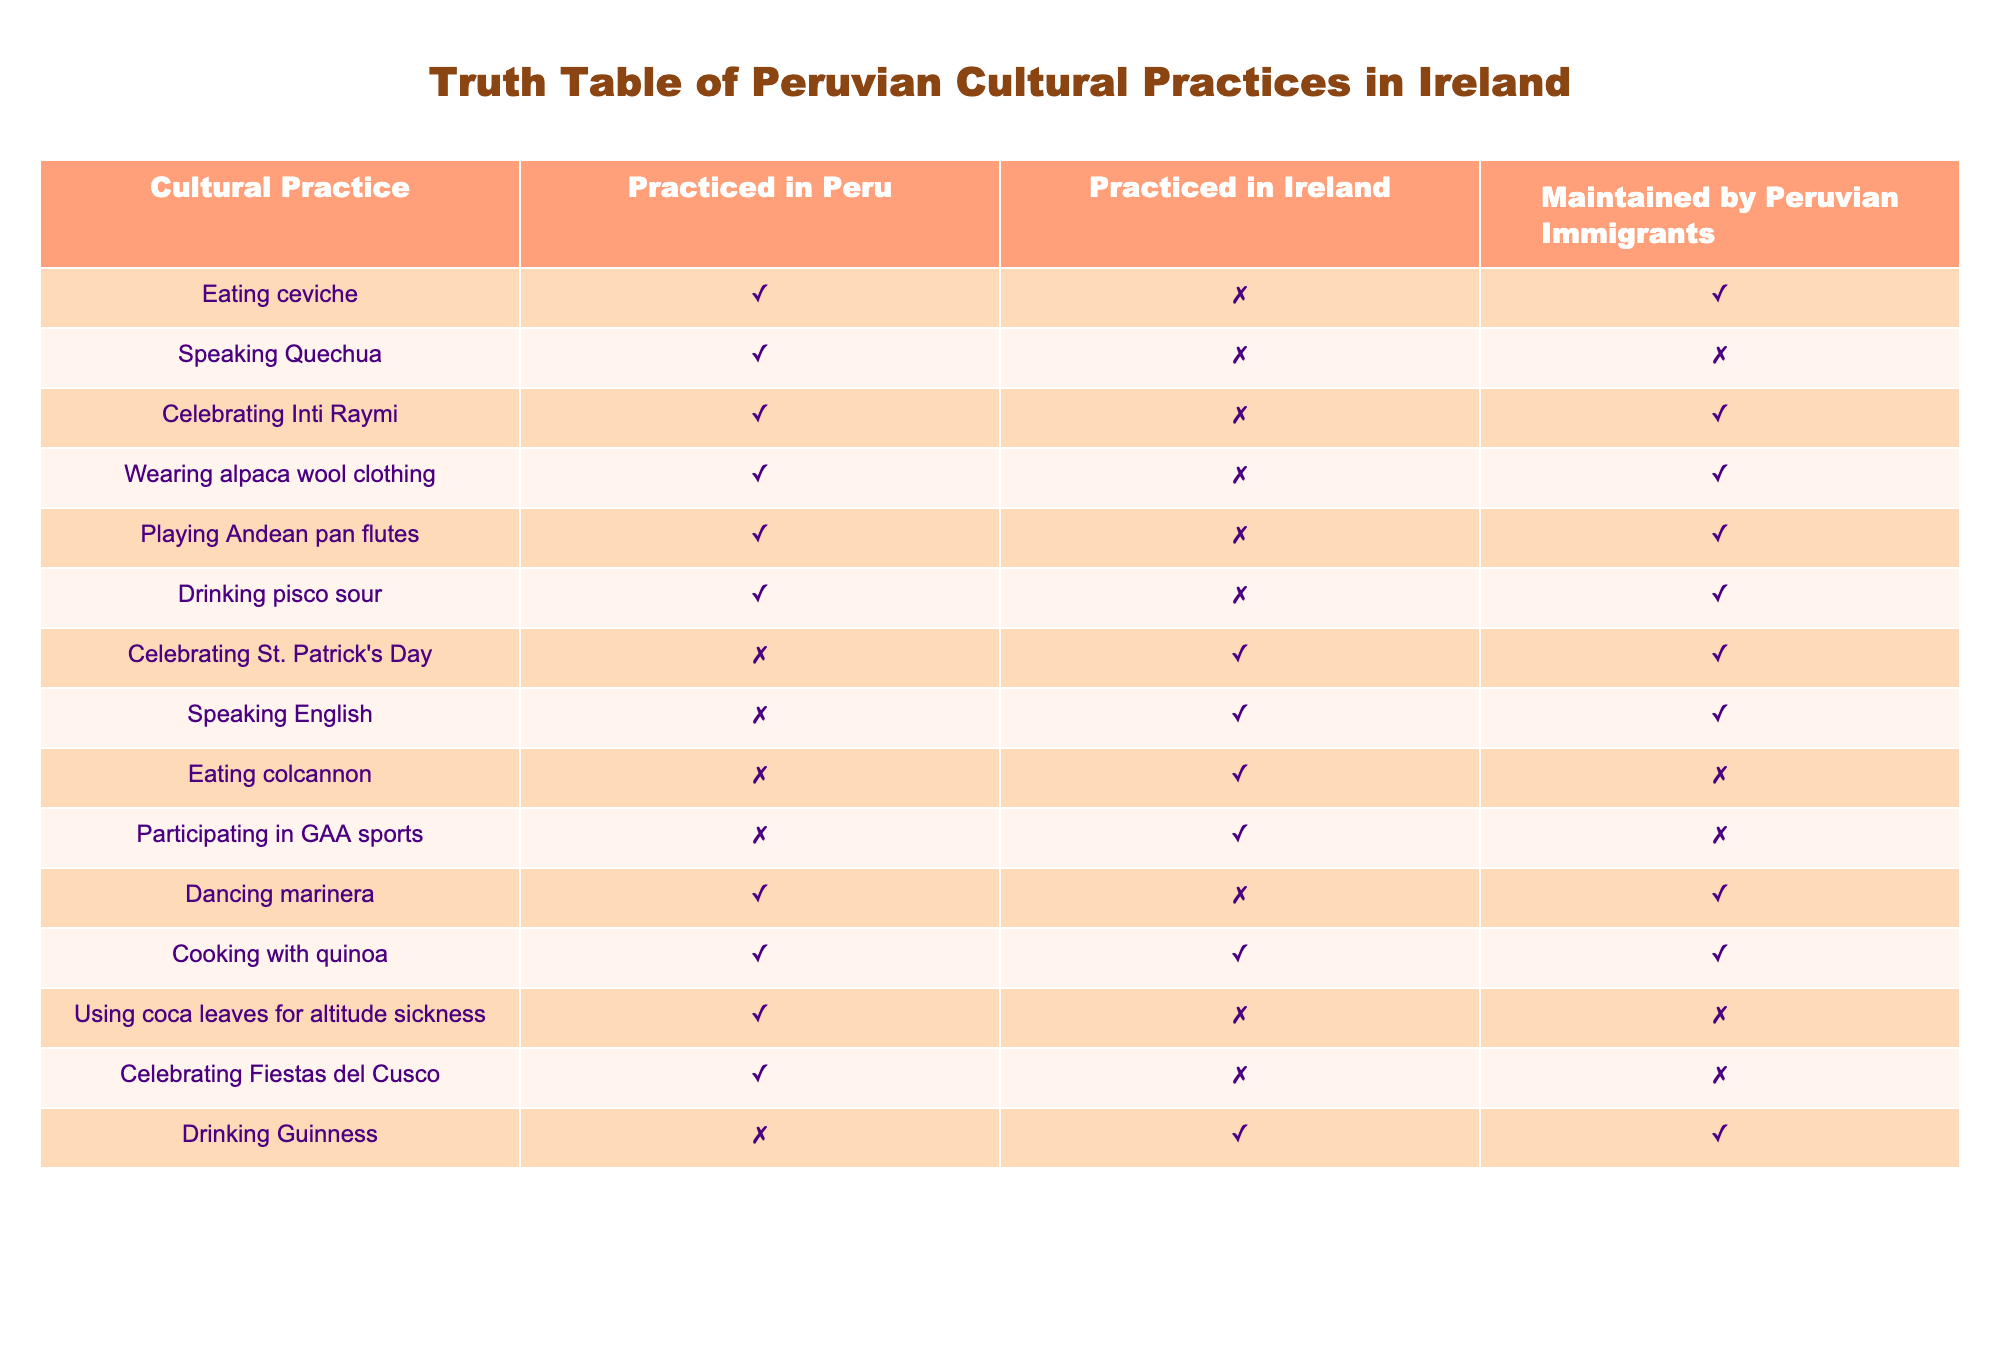What cultural practices are maintained by Peruvian immigrants in Ireland? To answer this, we look for the rows in the table where the column "Maintained by Peruvian Immigrants" is marked TRUE. The practices listed under this column are eating ceviche, celebrating Inti Raymi, wearing alpaca wool clothing, playing Andean pan flutes, drinking pisco sour, celebrating St. Patrick's Day, speaking English, dancing marinera, and cooking with quinoa.
Answer: Eating ceviche, celebrating Inti Raymi, wearing alpaca wool clothing, playing Andean pan flutes, drinking pisco sour, celebrating St. Patrick's Day, speaking English, dancing marinera, cooking with quinoa Is cooking with quinoa practiced in Ireland? To determine this, we refer to the row for "Cooking with quinoa" in the "Practiced in Ireland" column, which is marked TRUE.
Answer: Yes How many cultural practices are not practiced in Ireland? We count the rows that have FALSE under the "Practiced in Ireland" column. The practices are eating ceviche, speaking Quechua, celebrating Inti Raymi, wearing alpaca wool clothing, playing Andean pan flutes, drinking pisco sour, using coca leaves for altitude sickness, celebrating Fiestas del Cusco, and dancing marinera. There are 9 such practices.
Answer: 9 Do Peruvian immigrants maintain the practice of speaking Quechua? We can find this by looking for "Speaking Quechua" in the table. The column "Maintained by Peruvian Immigrants" for this practice shows FALSE, meaning it is not maintained.
Answer: No What is the total number of cultural practices that are both practiced in Peru and maintained by Peruvian immigrants? First, we identify the rows where both "Practiced in Peru" and "Maintained by Peruvian Immigrants" are TRUE. These include eating ceviche, celebrating Inti Raymi, wearing alpaca wool clothing, playing Andean pan flutes, drinking pisco sour, and dancing marinera, which gives us a total of 6 practices.
Answer: 6 Which cultural practice involves drinking and is not practiced in Peru? We locate the practices related to drinking where "Practiced in Peru" is FALSE. The only entry for this is drinking Guinness, which is practiced in Ireland.
Answer: Drinking Guinness What percentage of the cultural practices are celebrated in Ireland but are not originally from Peru? We first identify the practices celebrated in Ireland: celebrating St. Patrick's Day and eating colcannon. None of these practices are listed as practiced in Peru, yielding 2 non-Peruvian practices out of a total of 12 cultural practices from the table, which results in (2/12) * 100 = 16.67%.
Answer: 16.67% How many cultural practices involve clothing? The practices related to clothing are wearing alpaca wool clothing, counted in the table. There is only 1 such practice.
Answer: 1 What is the relationship between the cultural practices related to music and their maintenance by immigrants? The relevant practices in the context of music include playing Andean pan flutes and dancing marinera. Both are marked TRUE for "Maintained by Peruvian Immigrants," indicating these musical practices are upheld by immigrants.
Answer: Maintained by immigrants 